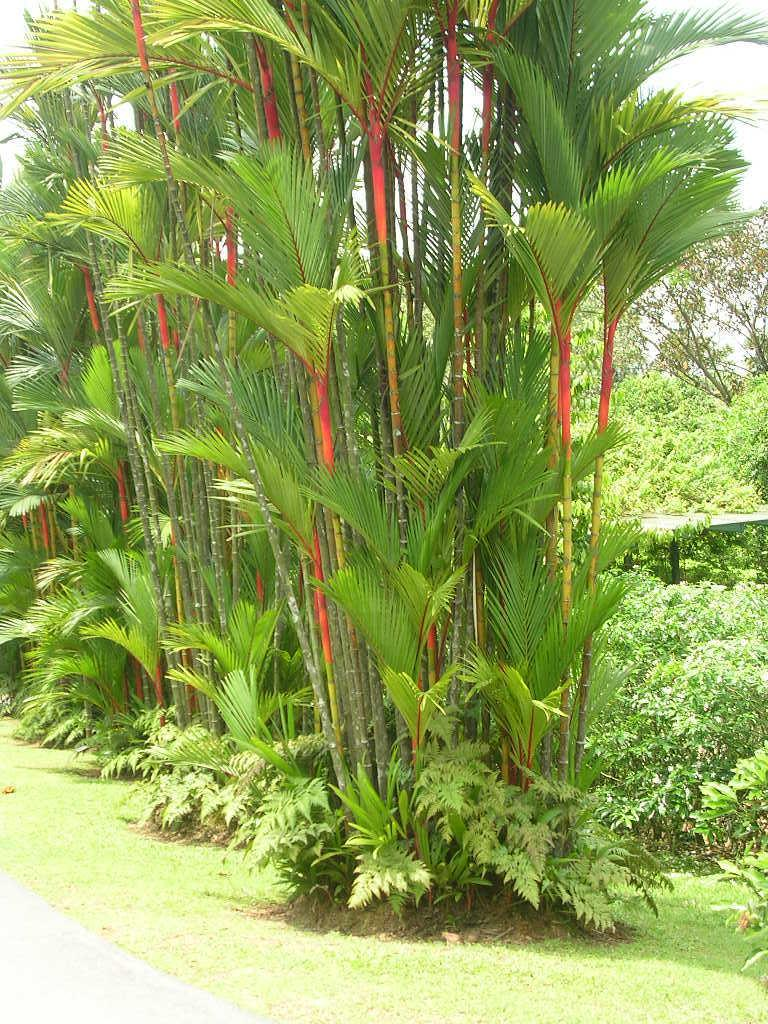What types of vegetation are present at the bottom of the image? The image contains plants and bushes at the bottom. What can be seen in the middle of the image? There are trees in the middle of the image. What space theory is being discussed in the image? There is no discussion of space theory in the image; it features plants, bushes, and trees. Is there any rain visible in the image? There is no rain visible in the image; it only shows vegetation. 